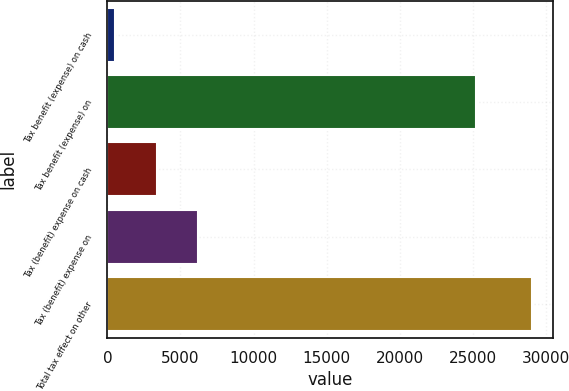Convert chart to OTSL. <chart><loc_0><loc_0><loc_500><loc_500><bar_chart><fcel>Tax benefit (expense) on cash<fcel>Tax benefit (expense) on<fcel>Tax (benefit) expense on cash<fcel>Tax (benefit) expense on<fcel>Total tax effect on other<nl><fcel>511<fcel>25193<fcel>3363.2<fcel>6215.4<fcel>29033<nl></chart> 